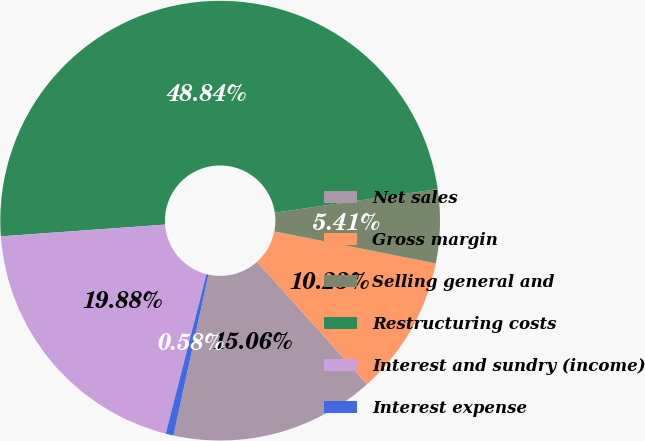<chart> <loc_0><loc_0><loc_500><loc_500><pie_chart><fcel>Net sales<fcel>Gross margin<fcel>Selling general and<fcel>Restructuring costs<fcel>Interest and sundry (income)<fcel>Interest expense<nl><fcel>15.06%<fcel>10.23%<fcel>5.41%<fcel>48.84%<fcel>19.88%<fcel>0.58%<nl></chart> 